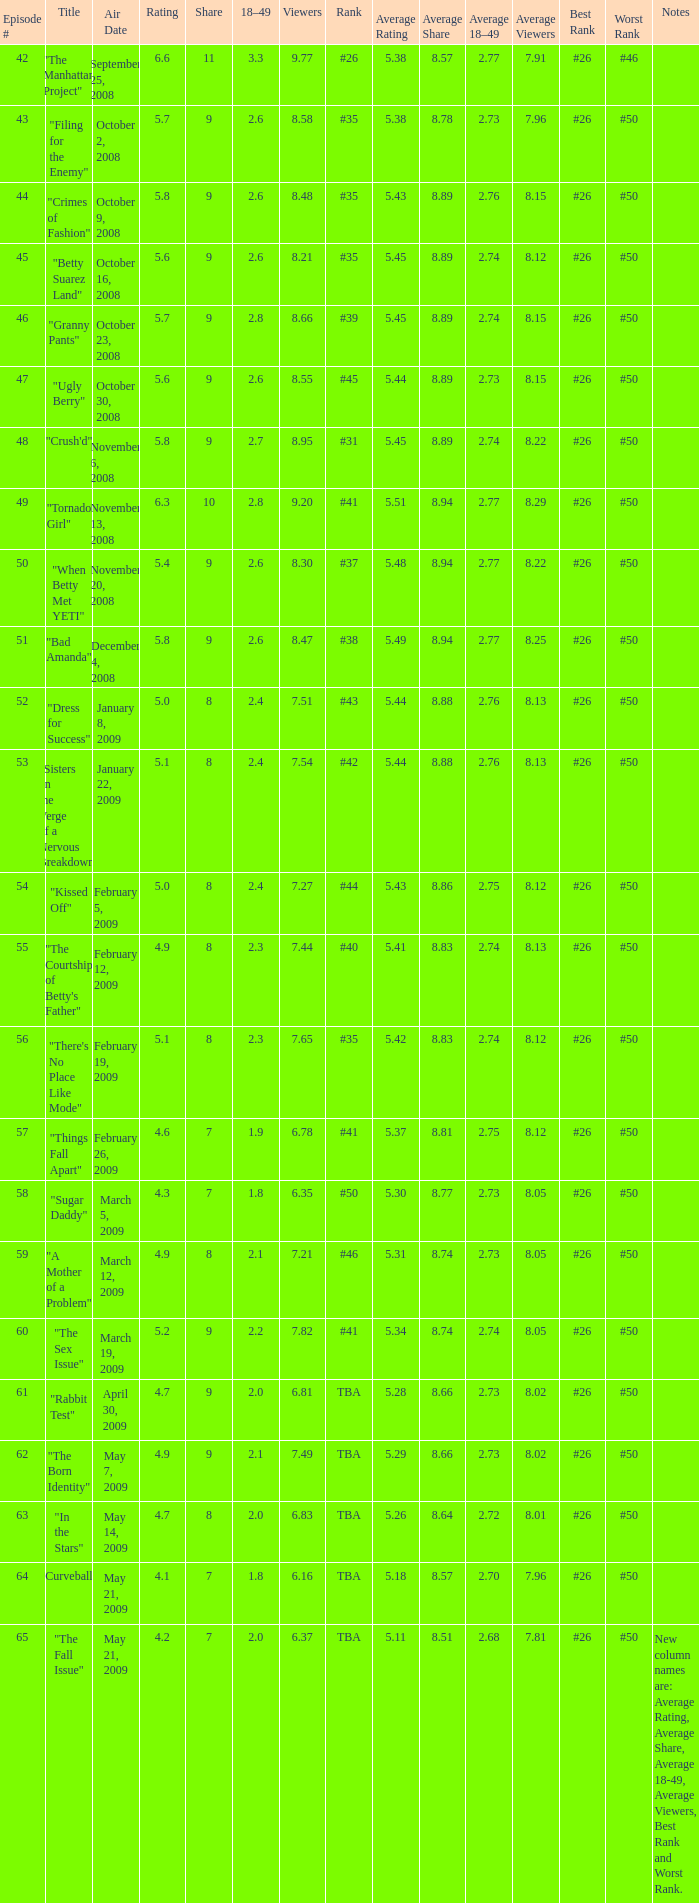What is the total number of Viewers when the rank is #40? 1.0. 